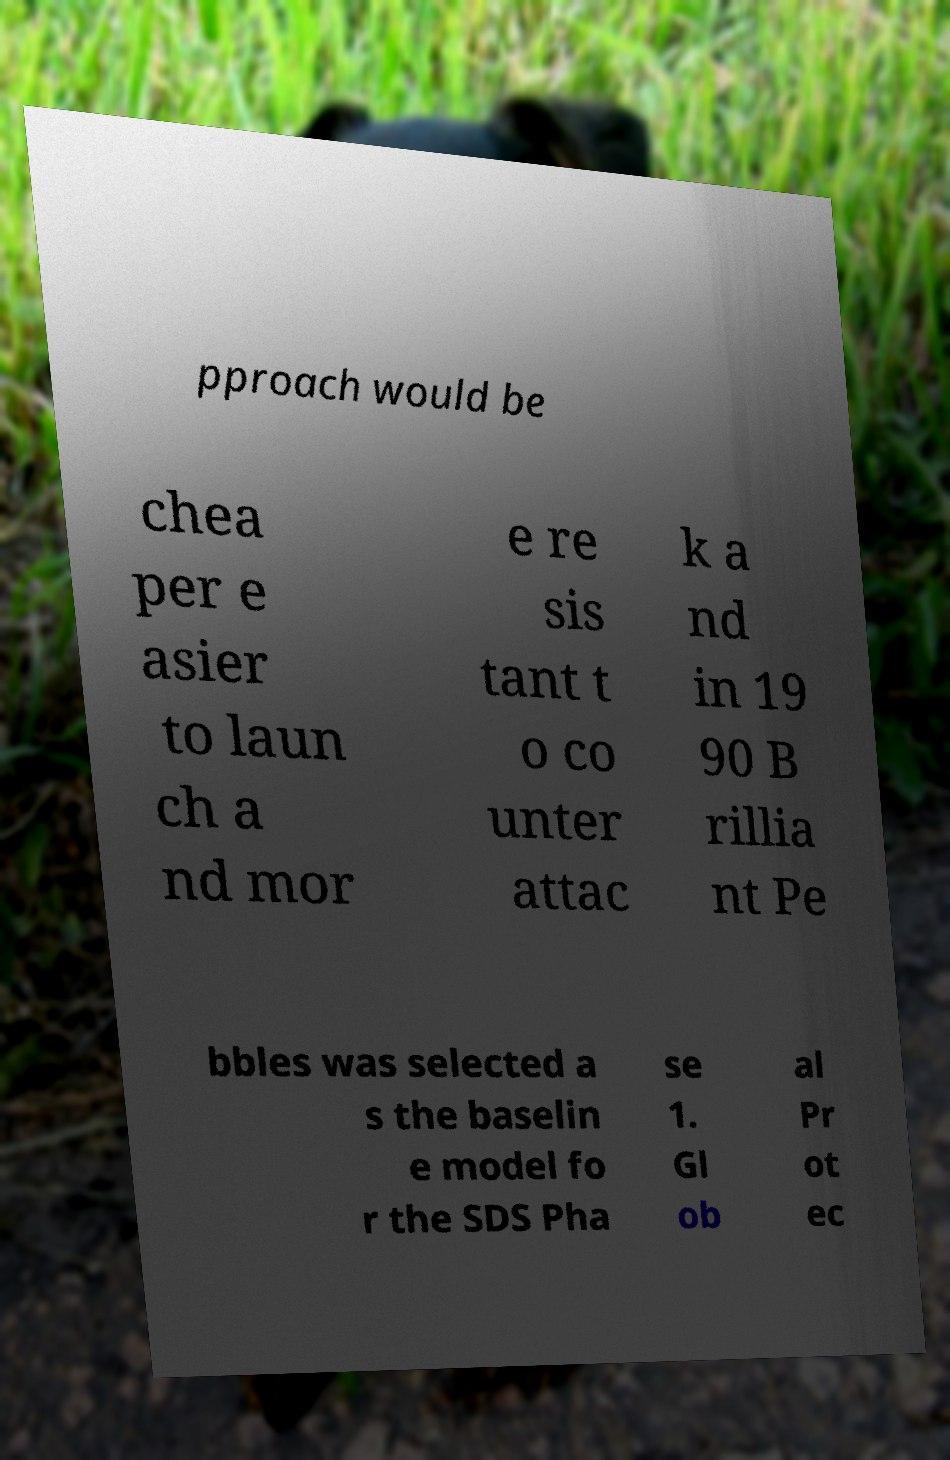Please identify and transcribe the text found in this image. pproach would be chea per e asier to laun ch a nd mor e re sis tant t o co unter attac k a nd in 19 90 B rillia nt Pe bbles was selected a s the baselin e model fo r the SDS Pha se 1. Gl ob al Pr ot ec 